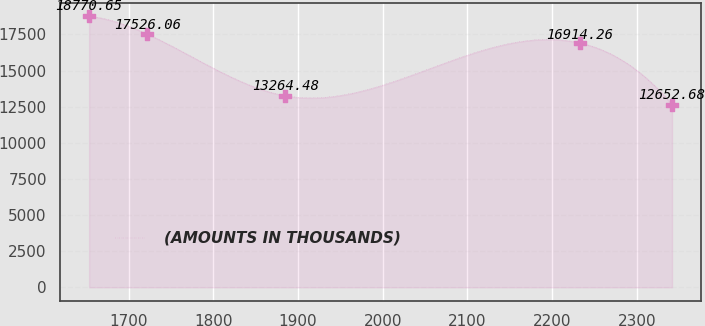<chart> <loc_0><loc_0><loc_500><loc_500><line_chart><ecel><fcel>(AMOUNTS IN THOUSANDS)<nl><fcel>1653.15<fcel>18770.7<nl><fcel>1722.01<fcel>17526.1<nl><fcel>1884.75<fcel>13264.5<nl><fcel>2233.21<fcel>16914.3<nl><fcel>2341.75<fcel>12652.7<nl></chart> 